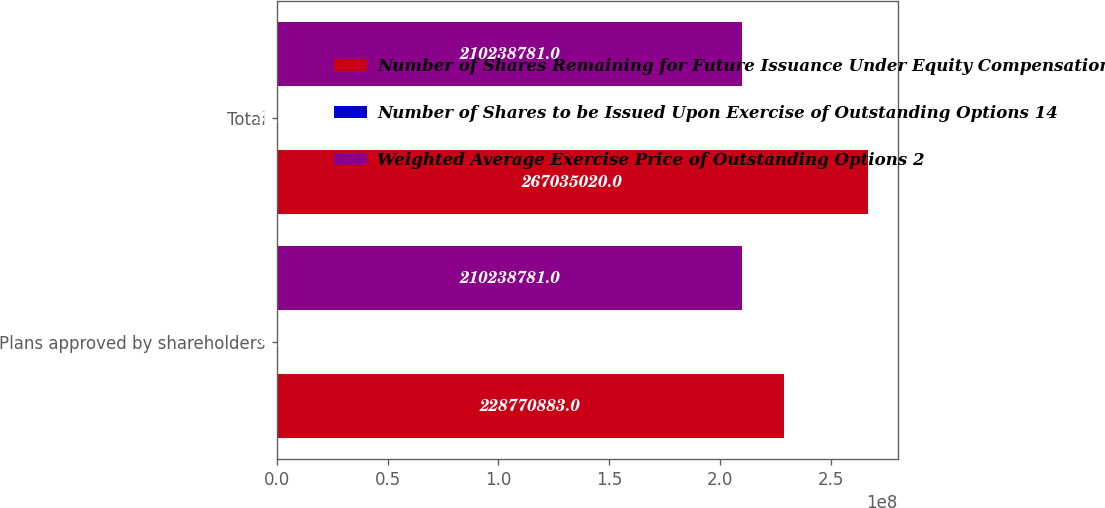Convert chart to OTSL. <chart><loc_0><loc_0><loc_500><loc_500><stacked_bar_chart><ecel><fcel>Plans approved by shareholders<fcel>Total<nl><fcel>Number of Shares Remaining for Future Issuance Under Equity Compensation Plans 3<fcel>2.28771e+08<fcel>2.67035e+08<nl><fcel>Number of Shares to be Issued Upon Exercise of Outstanding Options 14<fcel>33.69<fcel>33.09<nl><fcel>Weighted Average Exercise Price of Outstanding Options 2<fcel>2.10239e+08<fcel>2.10239e+08<nl></chart> 